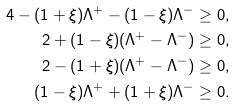Convert formula to latex. <formula><loc_0><loc_0><loc_500><loc_500>4 - ( 1 + \xi ) \Lambda ^ { + } - ( 1 - \xi ) \Lambda ^ { - } & \geq 0 , \\ 2 + ( 1 - \xi ) ( \Lambda ^ { + } - \Lambda ^ { - } ) & \geq 0 , \\ 2 - ( 1 + \xi ) ( \Lambda ^ { + } - \Lambda ^ { - } ) & \geq 0 , \\ ( 1 - \xi ) \Lambda ^ { + } + ( 1 + \xi ) \Lambda ^ { - } & \geq 0 .</formula> 